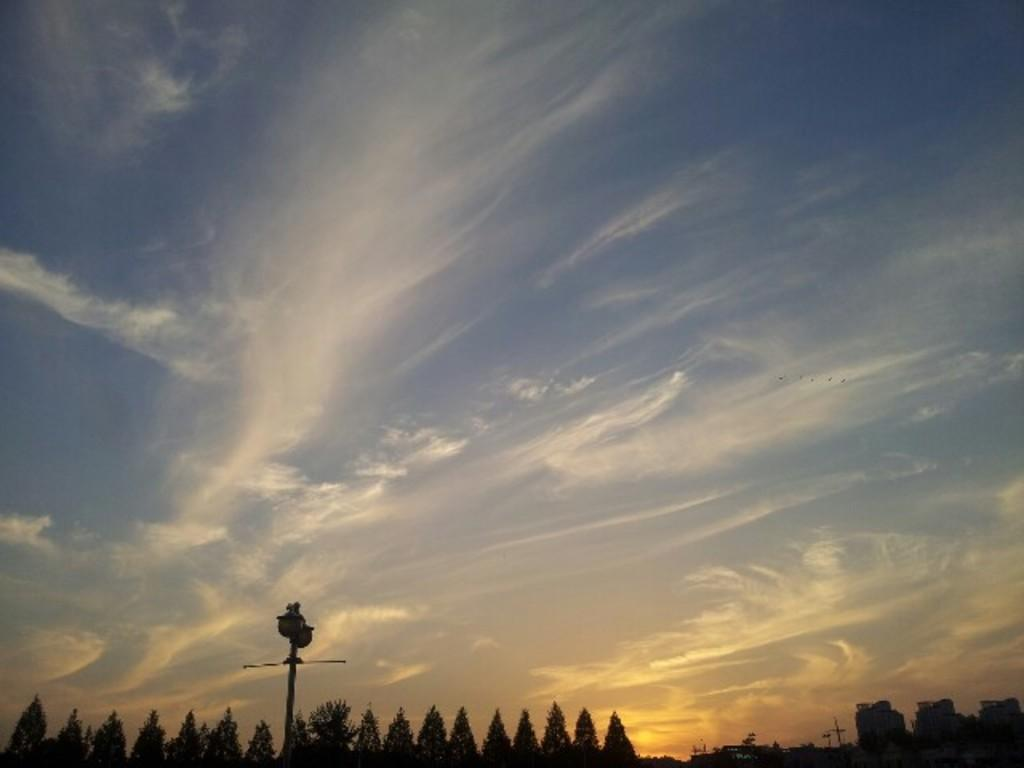What type of vegetation can be seen in the image? There are trees in the image. What structure is present in the image? There is a pole in the image. What is visible in the sky in the image? The sky is visible in the image and appears to be cloudy. What color is the shirt hanging on the hook in the image? There is no shirt or hook present in the image. How does the pole shake in the image? The pole does not shake in the image; it is stationary. 